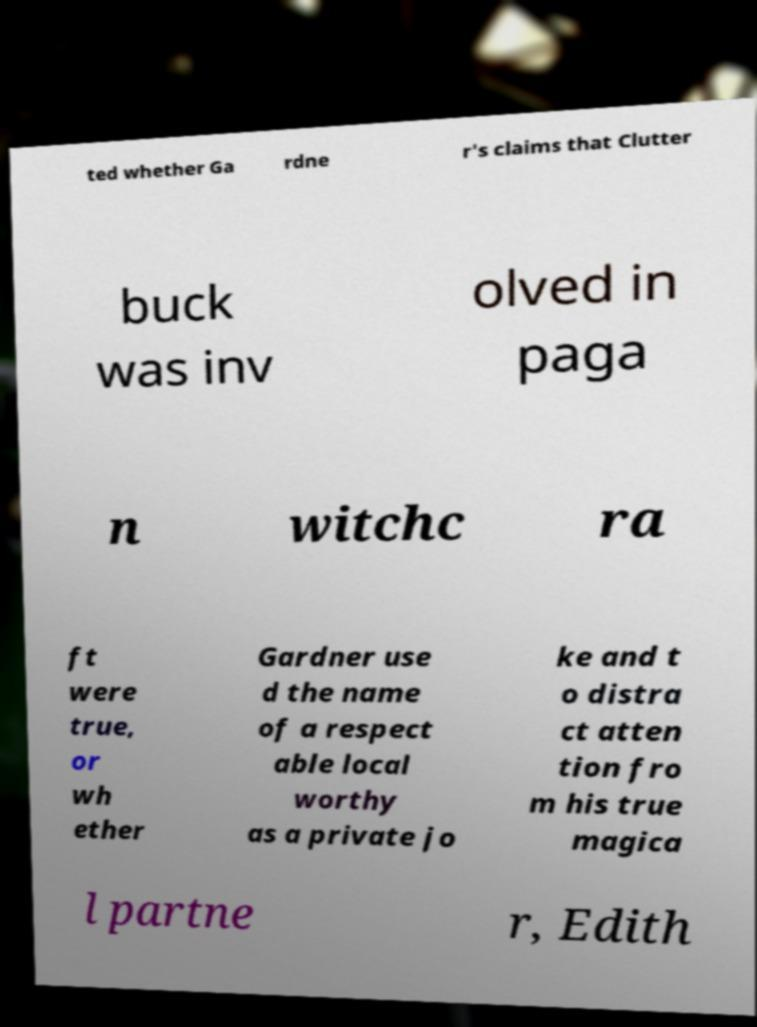Could you assist in decoding the text presented in this image and type it out clearly? ted whether Ga rdne r's claims that Clutter buck was inv olved in paga n witchc ra ft were true, or wh ether Gardner use d the name of a respect able local worthy as a private jo ke and t o distra ct atten tion fro m his true magica l partne r, Edith 